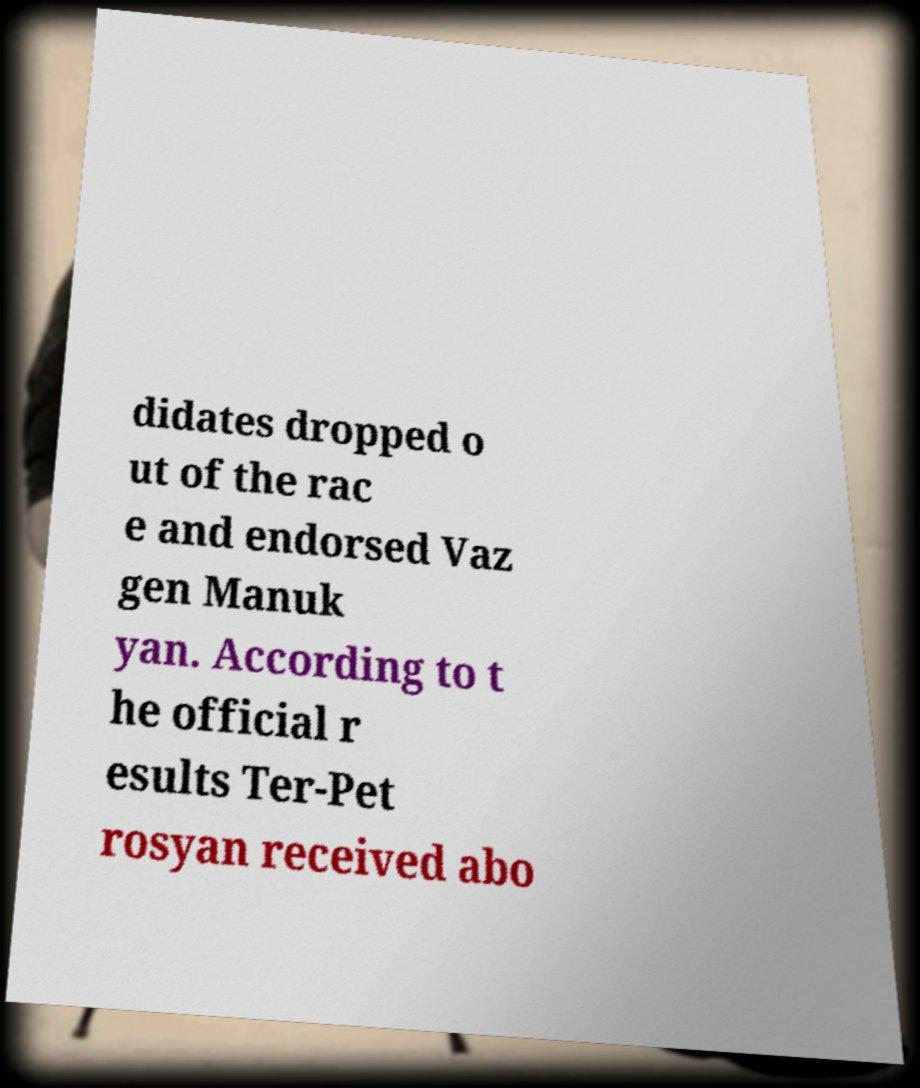What messages or text are displayed in this image? I need them in a readable, typed format. didates dropped o ut of the rac e and endorsed Vaz gen Manuk yan. According to t he official r esults Ter-Pet rosyan received abo 